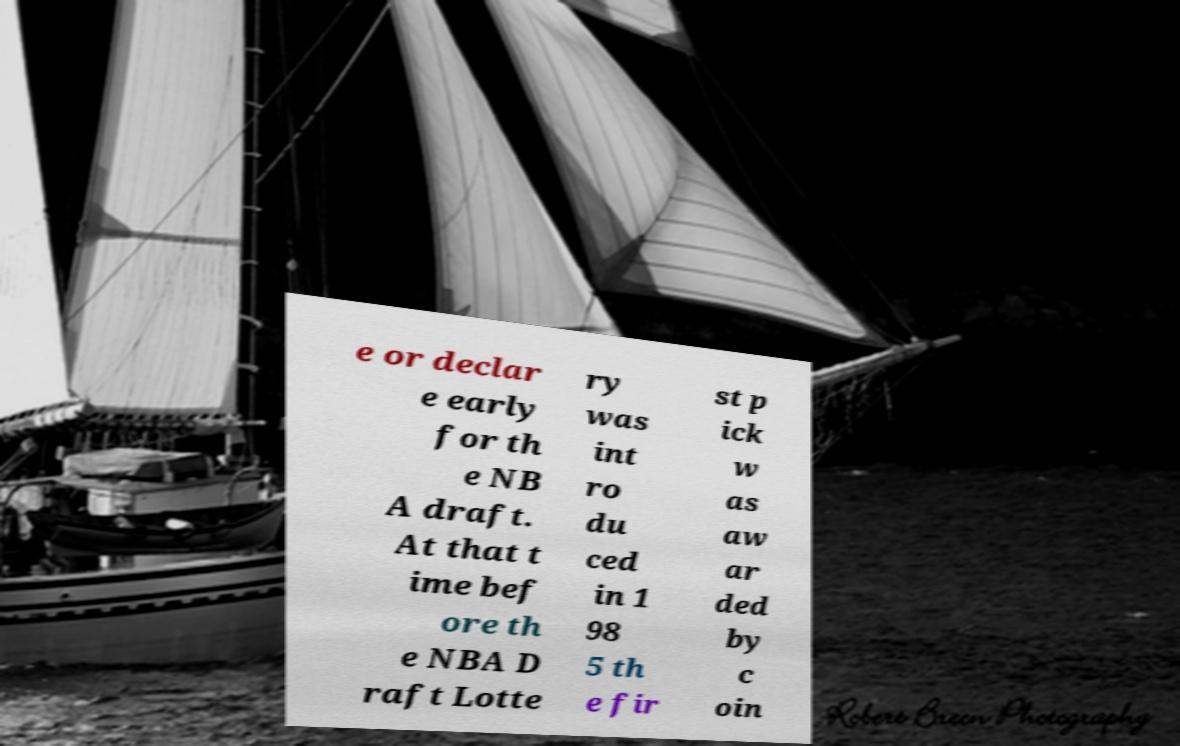Can you accurately transcribe the text from the provided image for me? e or declar e early for th e NB A draft. At that t ime bef ore th e NBA D raft Lotte ry was int ro du ced in 1 98 5 th e fir st p ick w as aw ar ded by c oin 